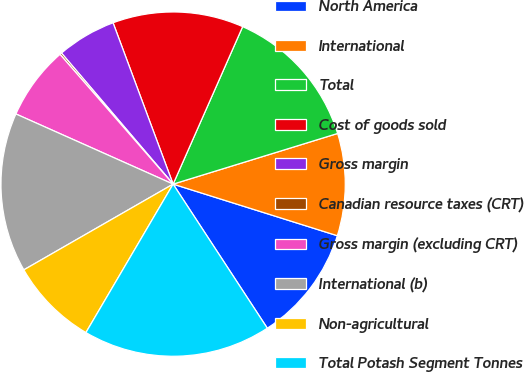Convert chart to OTSL. <chart><loc_0><loc_0><loc_500><loc_500><pie_chart><fcel>North America<fcel>International<fcel>Total<fcel>Cost of goods sold<fcel>Gross margin<fcel>Canadian resource taxes (CRT)<fcel>Gross margin (excluding CRT)<fcel>International (b)<fcel>Non-agricultural<fcel>Total Potash Segment Tonnes<nl><fcel>10.94%<fcel>9.6%<fcel>13.63%<fcel>12.29%<fcel>5.56%<fcel>0.18%<fcel>6.91%<fcel>14.98%<fcel>8.25%<fcel>17.67%<nl></chart> 